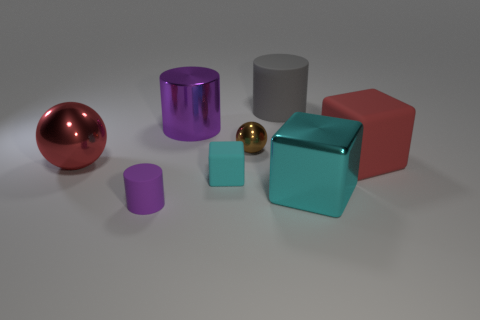Add 1 green matte cylinders. How many objects exist? 9 Subtract all cubes. How many objects are left? 5 Add 7 cyan rubber cubes. How many cyan rubber cubes are left? 8 Add 4 large red cubes. How many large red cubes exist? 5 Subtract 0 blue balls. How many objects are left? 8 Subtract all big rubber cubes. Subtract all large matte objects. How many objects are left? 5 